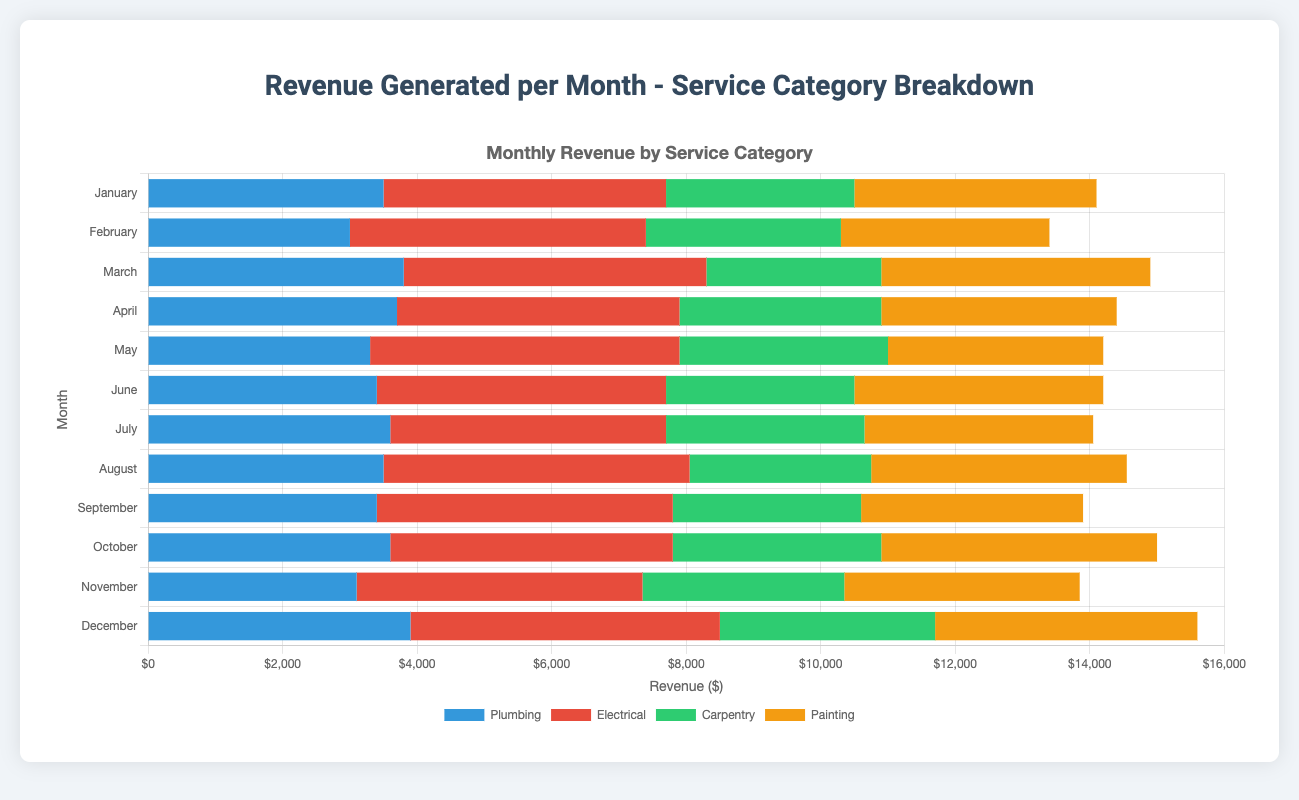Which service category generated the highest revenue in March? Identify the service categories for March and visually compare the bar lengths; Electrical has the tallest bar.
Answer: Electrical What's the total revenue generated in May? Sum up the revenues for Plumbing, Electrical, Carpentry, and Painting for May: 3300 + 4600 + 3100 + 3200 = 14200.
Answer: 14200 How does the revenue from Painting in June compare to the revenue from Painting in August? Locate the Painting bars for June and August; June's bar is shorter than August's.
Answer: Less By how much does the total revenue in December differ from the total revenue in September? Calculate the total revenues for both months and find the difference: December: 3900 + 4600 + 3200 + 3900 = 15600, September: 3400+4400+2800+3300 = 13900, Difference: 15600 - 13900 = 1700.
Answer: 1700 Which month had the lowest revenue generated from Carpentry? Visually compare the heights of the Carpentry bars across all months to identify the shortest; March has the shortest bar.
Answer: March What is the average monthly revenue generated from Electrical services? Calculate the total Electrical revenue and divide by the number of months: (4200 + 4400 + 4500 + 4200 + 4600 + 4300 + 4100 + 4550 + 4400 + 4200 + 4250 + 4600) / 12 = 4400.
Answer: 4400 How does the combined revenue from Plumbing and Carpentry in April compare to the combined revenue from Painting and Electrical in the same month? Calculate the combined revenues: Plumbing + Carpentry in April = 3700 + 3000 = 6700, Painting + Electrical in April = 3500 + 4200 = 7700, 7700 - 6700 = 1000.
Answer: Lower by 1000 Which month shows a higher revenue from Plumbing, January or December? Visually compare the Plumbing bars for January and December; December's Plumbing bar is taller.
Answer: December In which month does Painting have the second highest revenue? Visually compare the Painting bars and identify the second tallest bar, October has the second tallest bar.
Answer: October 